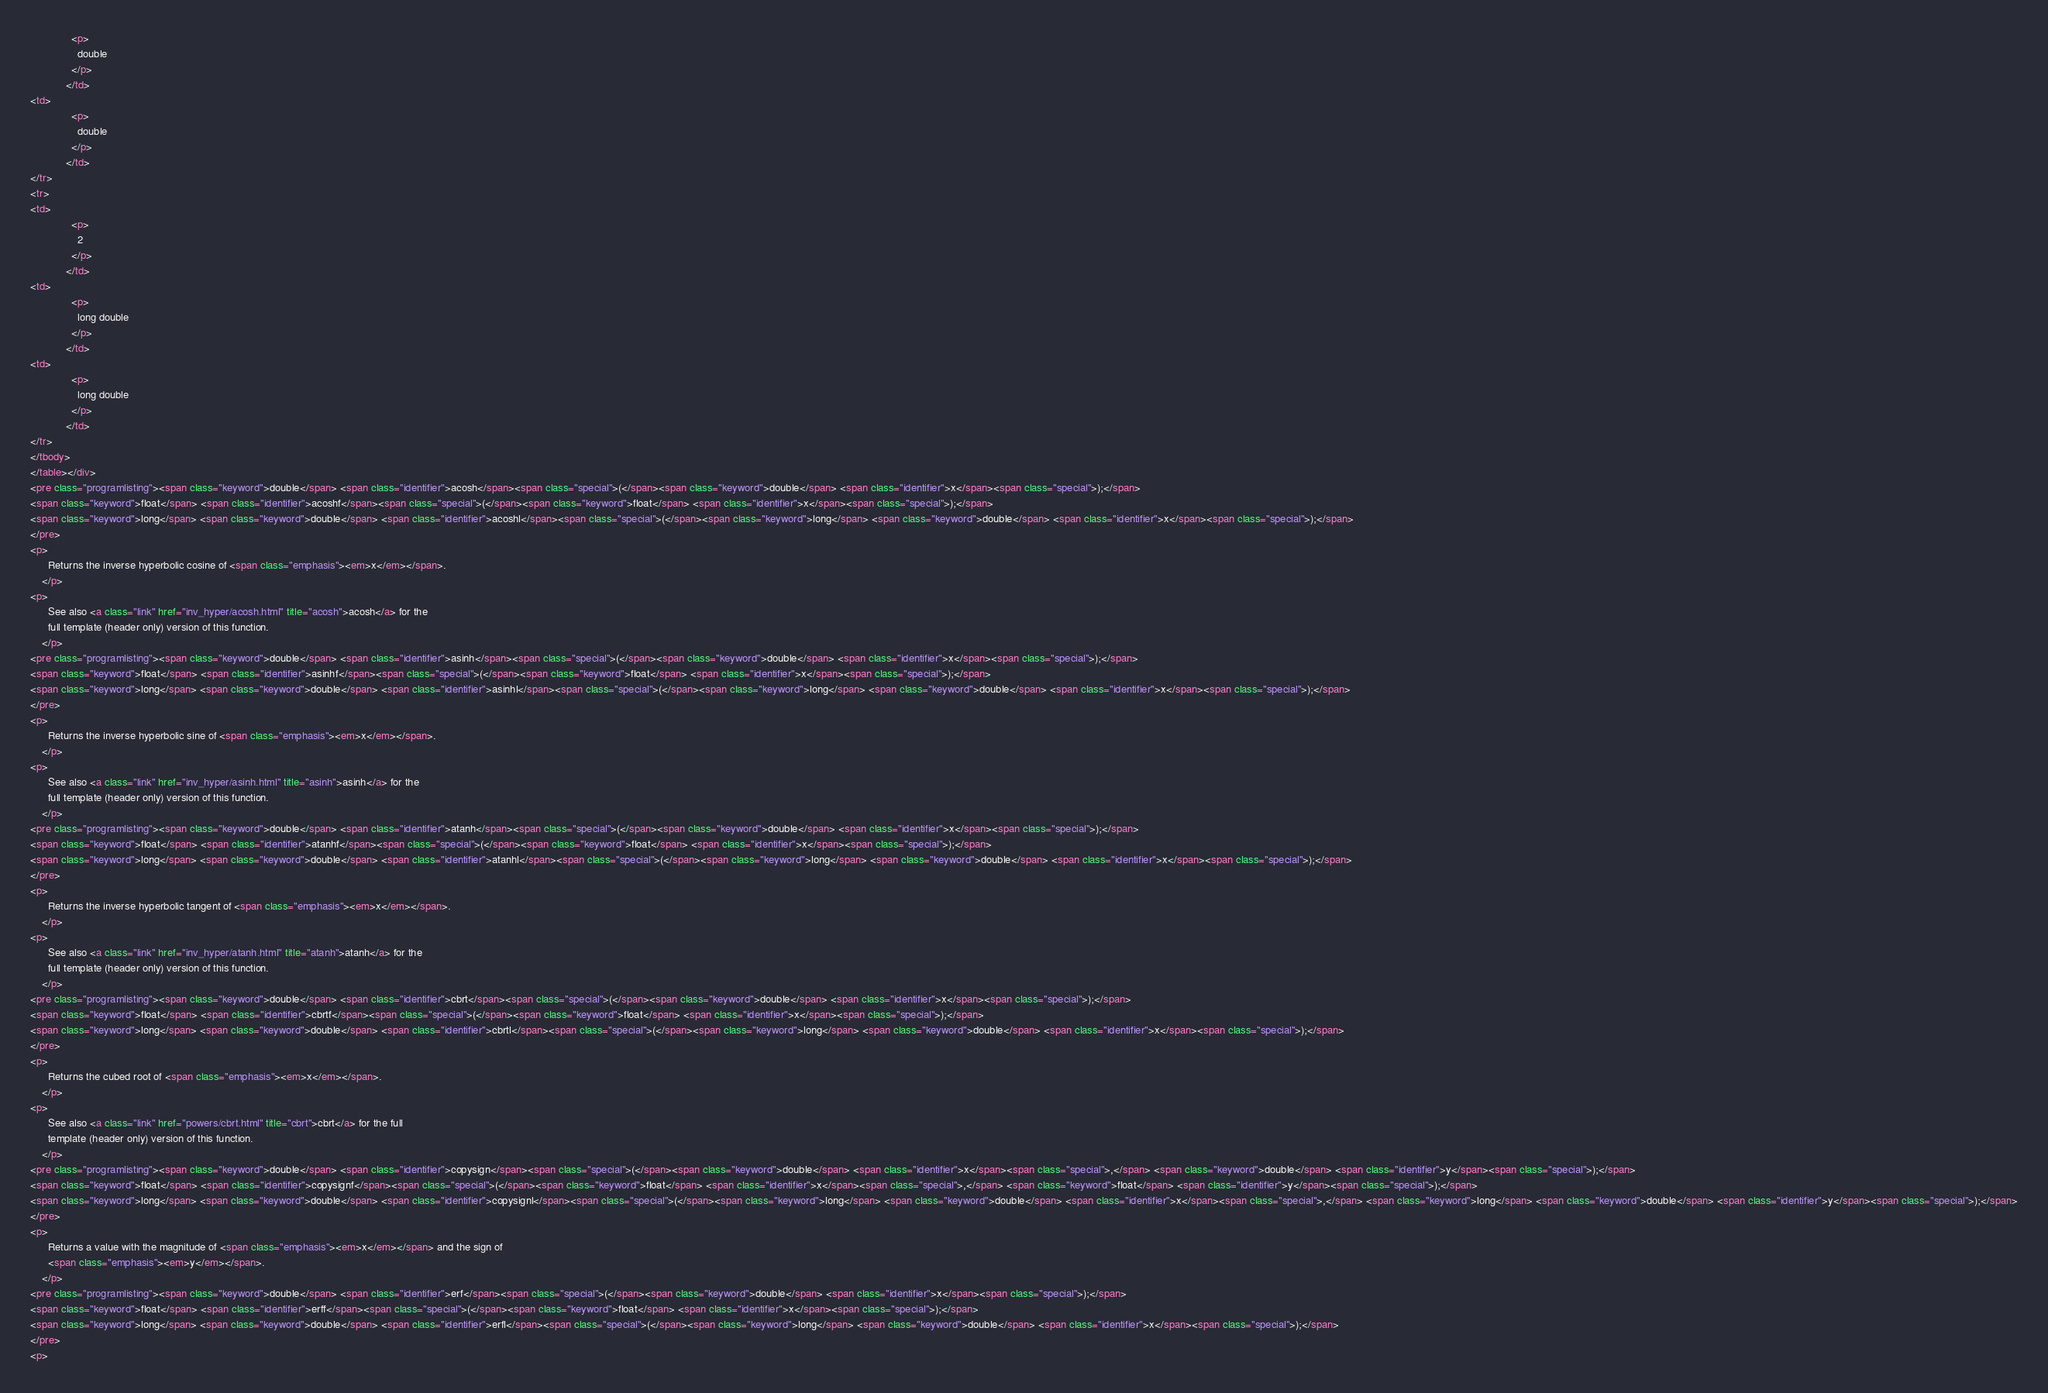Convert code to text. <code><loc_0><loc_0><loc_500><loc_500><_HTML_>              <p>
                double
              </p>
            </td>
<td>
              <p>
                double
              </p>
            </td>
</tr>
<tr>
<td>
              <p>
                2
              </p>
            </td>
<td>
              <p>
                long double
              </p>
            </td>
<td>
              <p>
                long double
              </p>
            </td>
</tr>
</tbody>
</table></div>
<pre class="programlisting"><span class="keyword">double</span> <span class="identifier">acosh</span><span class="special">(</span><span class="keyword">double</span> <span class="identifier">x</span><span class="special">);</span>
<span class="keyword">float</span> <span class="identifier">acoshf</span><span class="special">(</span><span class="keyword">float</span> <span class="identifier">x</span><span class="special">);</span>
<span class="keyword">long</span> <span class="keyword">double</span> <span class="identifier">acoshl</span><span class="special">(</span><span class="keyword">long</span> <span class="keyword">double</span> <span class="identifier">x</span><span class="special">);</span>
</pre>
<p>
      Returns the inverse hyperbolic cosine of <span class="emphasis"><em>x</em></span>.
    </p>
<p>
      See also <a class="link" href="inv_hyper/acosh.html" title="acosh">acosh</a> for the
      full template (header only) version of this function.
    </p>
<pre class="programlisting"><span class="keyword">double</span> <span class="identifier">asinh</span><span class="special">(</span><span class="keyword">double</span> <span class="identifier">x</span><span class="special">);</span>
<span class="keyword">float</span> <span class="identifier">asinhf</span><span class="special">(</span><span class="keyword">float</span> <span class="identifier">x</span><span class="special">);</span>
<span class="keyword">long</span> <span class="keyword">double</span> <span class="identifier">asinhl</span><span class="special">(</span><span class="keyword">long</span> <span class="keyword">double</span> <span class="identifier">x</span><span class="special">);</span>
</pre>
<p>
      Returns the inverse hyperbolic sine of <span class="emphasis"><em>x</em></span>.
    </p>
<p>
      See also <a class="link" href="inv_hyper/asinh.html" title="asinh">asinh</a> for the
      full template (header only) version of this function.
    </p>
<pre class="programlisting"><span class="keyword">double</span> <span class="identifier">atanh</span><span class="special">(</span><span class="keyword">double</span> <span class="identifier">x</span><span class="special">);</span>
<span class="keyword">float</span> <span class="identifier">atanhf</span><span class="special">(</span><span class="keyword">float</span> <span class="identifier">x</span><span class="special">);</span>
<span class="keyword">long</span> <span class="keyword">double</span> <span class="identifier">atanhl</span><span class="special">(</span><span class="keyword">long</span> <span class="keyword">double</span> <span class="identifier">x</span><span class="special">);</span>
</pre>
<p>
      Returns the inverse hyperbolic tangent of <span class="emphasis"><em>x</em></span>.
    </p>
<p>
      See also <a class="link" href="inv_hyper/atanh.html" title="atanh">atanh</a> for the
      full template (header only) version of this function.
    </p>
<pre class="programlisting"><span class="keyword">double</span> <span class="identifier">cbrt</span><span class="special">(</span><span class="keyword">double</span> <span class="identifier">x</span><span class="special">);</span>
<span class="keyword">float</span> <span class="identifier">cbrtf</span><span class="special">(</span><span class="keyword">float</span> <span class="identifier">x</span><span class="special">);</span>
<span class="keyword">long</span> <span class="keyword">double</span> <span class="identifier">cbrtl</span><span class="special">(</span><span class="keyword">long</span> <span class="keyword">double</span> <span class="identifier">x</span><span class="special">);</span>
</pre>
<p>
      Returns the cubed root of <span class="emphasis"><em>x</em></span>.
    </p>
<p>
      See also <a class="link" href="powers/cbrt.html" title="cbrt">cbrt</a> for the full
      template (header only) version of this function.
    </p>
<pre class="programlisting"><span class="keyword">double</span> <span class="identifier">copysign</span><span class="special">(</span><span class="keyword">double</span> <span class="identifier">x</span><span class="special">,</span> <span class="keyword">double</span> <span class="identifier">y</span><span class="special">);</span>
<span class="keyword">float</span> <span class="identifier">copysignf</span><span class="special">(</span><span class="keyword">float</span> <span class="identifier">x</span><span class="special">,</span> <span class="keyword">float</span> <span class="identifier">y</span><span class="special">);</span>
<span class="keyword">long</span> <span class="keyword">double</span> <span class="identifier">copysignl</span><span class="special">(</span><span class="keyword">long</span> <span class="keyword">double</span> <span class="identifier">x</span><span class="special">,</span> <span class="keyword">long</span> <span class="keyword">double</span> <span class="identifier">y</span><span class="special">);</span>
</pre>
<p>
      Returns a value with the magnitude of <span class="emphasis"><em>x</em></span> and the sign of
      <span class="emphasis"><em>y</em></span>.
    </p>
<pre class="programlisting"><span class="keyword">double</span> <span class="identifier">erf</span><span class="special">(</span><span class="keyword">double</span> <span class="identifier">x</span><span class="special">);</span>
<span class="keyword">float</span> <span class="identifier">erff</span><span class="special">(</span><span class="keyword">float</span> <span class="identifier">x</span><span class="special">);</span>
<span class="keyword">long</span> <span class="keyword">double</span> <span class="identifier">erfl</span><span class="special">(</span><span class="keyword">long</span> <span class="keyword">double</span> <span class="identifier">x</span><span class="special">);</span>
</pre>
<p></code> 